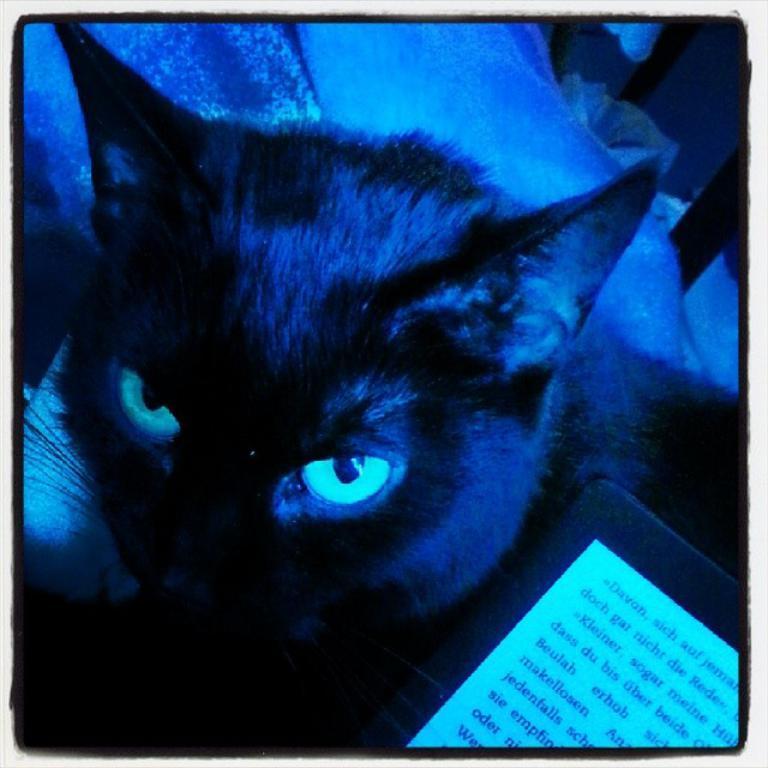How would you summarize this image in a sentence or two? In the image we can see a cat, gadget, screen and a text. 